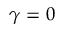<formula> <loc_0><loc_0><loc_500><loc_500>\gamma = 0</formula> 